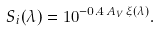<formula> <loc_0><loc_0><loc_500><loc_500>S _ { i } ( \lambda ) = 1 0 ^ { - 0 . 4 \, A _ { V } \, \xi ( \lambda ) } .</formula> 